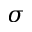<formula> <loc_0><loc_0><loc_500><loc_500>\sigma</formula> 